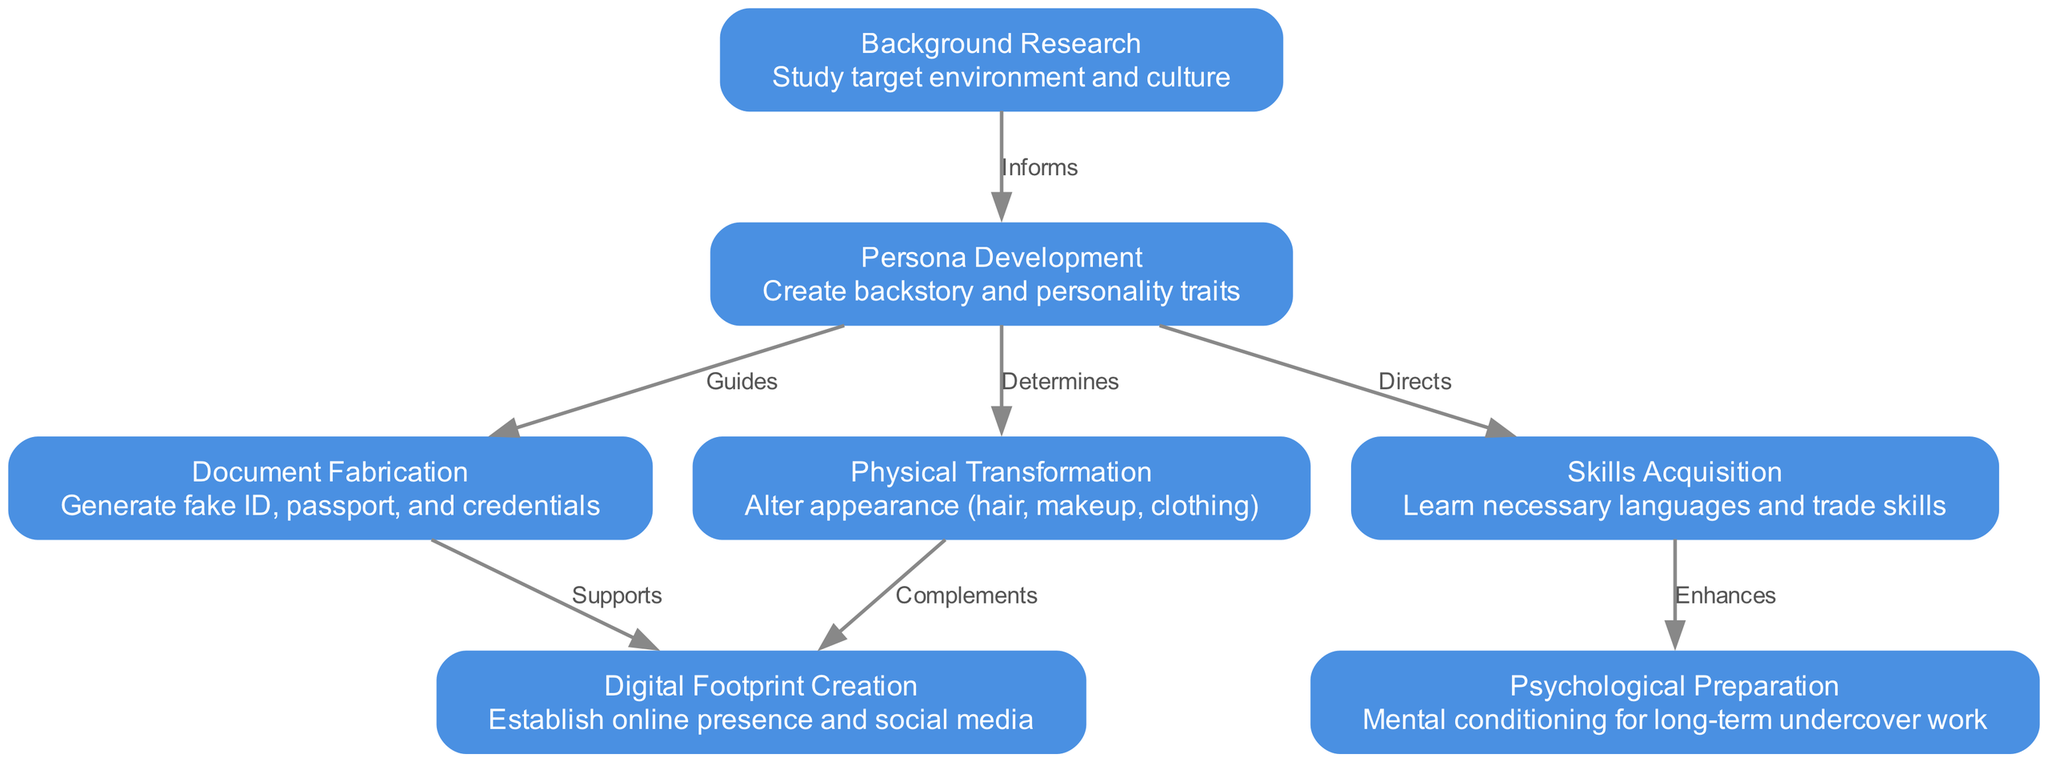What is the first step in the identity creation process? The first step listed in the diagram is "Background Research," which is denoted by the node with the ID 1. It involves studying the target environment and culture.
Answer: Background Research How many steps are there in the identity creation process? By counting the number of nodes in the diagram, we see 7 steps listed, from "Background Research" to "Psychological Preparation."
Answer: 7 Which step directly informs Persona Development? According to the connections in the diagram, "Background Research" (ID 1) informs "Persona Development" (ID 2), as indicated by the directed edge between them.
Answer: Background Research What type of relationship exists between Persona Development and Document Fabrication? The diagram indicates that "Persona Development" guides "Document Fabrication" as there is a directed edge labeled "Guides" from node 2 to node 3.
Answer: Guides Which step is enhanced by Skills Acquisition? The diagram shows that "Psychological Preparation" (ID 7) is enhanced by "Skills Acquisition" (ID 5) due to the directed edge labeled "Enhances."
Answer: Psychological Preparation What is the relationship between Document Fabrication and Digital Footprint Creation? "Document Fabrication" supports the creation of a "Digital Footprint," which is evident from the directed edge labeled "Supports" from node 3 to node 6.
Answer: Supports Which two steps are directly connected to Persona Development? The diagram shows that Persona Development (ID 2) is connected to Document Fabrication (ID 3), Physical Transformation (ID 4), and Skills Acquisition (ID 5), but only the first two are directly connected by edges labeled "Guides" and "Determines," respectively.
Answer: Document Fabrication and Physical Transformation What action is described in the step of Physical Transformation? The details for the step labeled "Physical Transformation" mention altering appearance through hair, makeup, and clothing, which is directly stated in the node details.
Answer: Alter appearance Which step comes after Document Fabrication in the sequence? By following the directed flow of the diagram, Document Fabrication (ID 3) is followed by Digital Footprint Creation (ID 6).
Answer: Digital Footprint Creation 